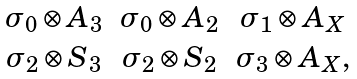Convert formula to latex. <formula><loc_0><loc_0><loc_500><loc_500>\begin{array} { c c c } \sigma _ { 0 } \otimes A _ { 3 } & \sigma _ { 0 } \otimes A _ { 2 } & \sigma _ { 1 } \otimes A _ { X } \\ \sigma _ { 2 } \otimes S _ { 3 } & \sigma _ { 2 } \otimes S _ { 2 } & \sigma _ { 3 } \otimes A _ { X } , \end{array}</formula> 